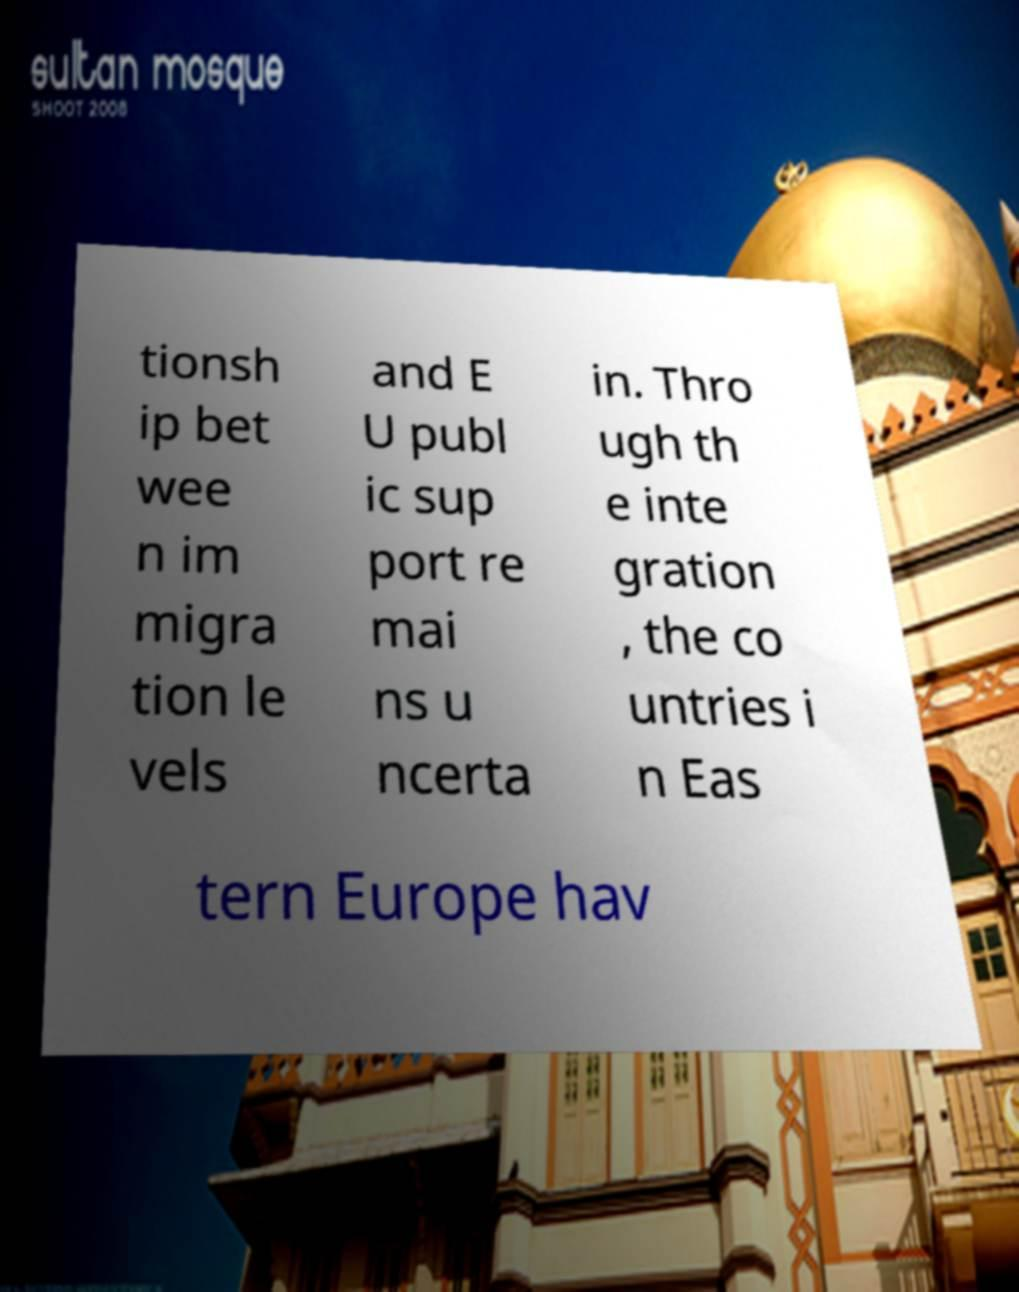I need the written content from this picture converted into text. Can you do that? tionsh ip bet wee n im migra tion le vels and E U publ ic sup port re mai ns u ncerta in. Thro ugh th e inte gration , the co untries i n Eas tern Europe hav 